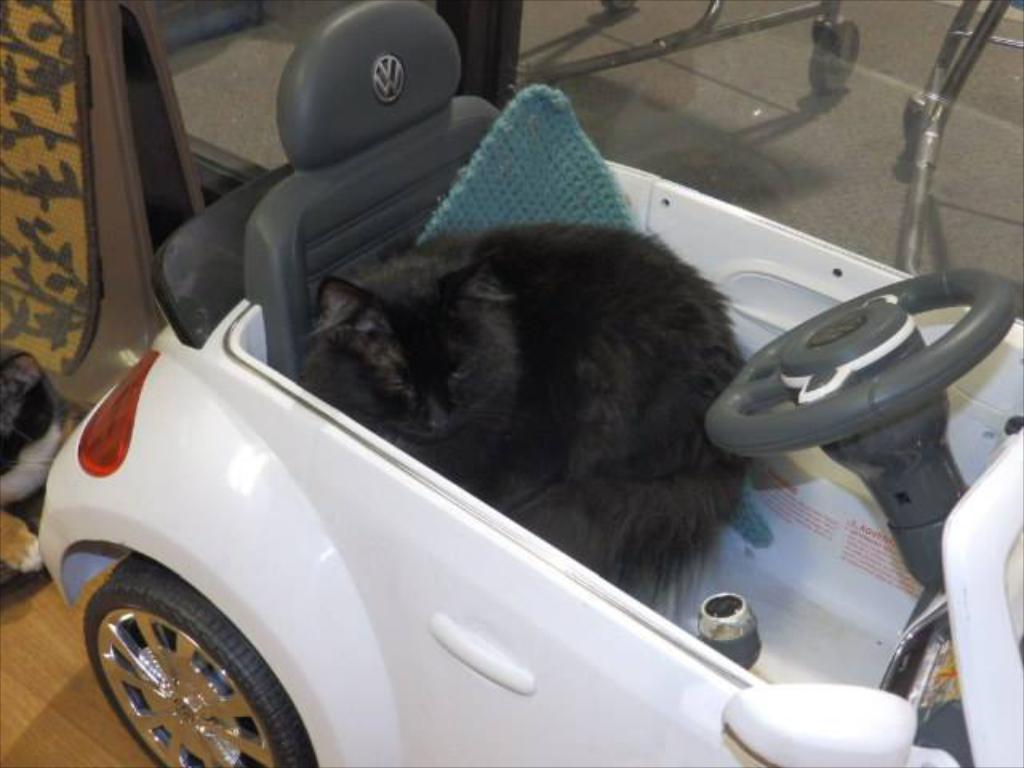Describe this image in one or two sentences. In this image I can see a cat sitting in the car. 